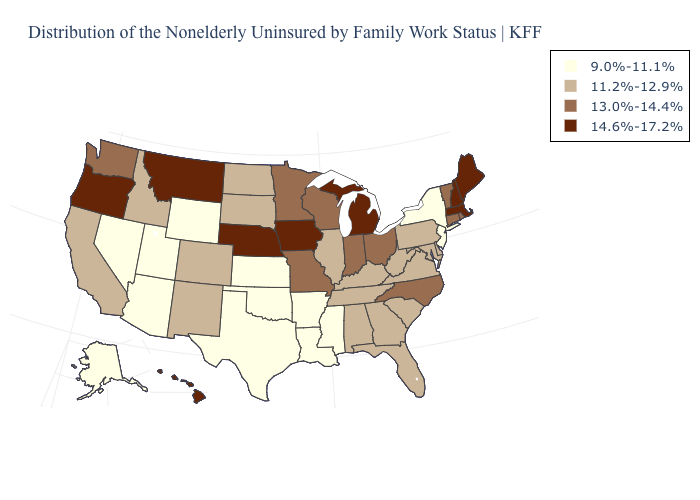Does Alaska have the lowest value in the USA?
Write a very short answer. Yes. Name the states that have a value in the range 14.6%-17.2%?
Keep it brief. Hawaii, Iowa, Maine, Massachusetts, Michigan, Montana, Nebraska, New Hampshire, Oregon. Name the states that have a value in the range 14.6%-17.2%?
Concise answer only. Hawaii, Iowa, Maine, Massachusetts, Michigan, Montana, Nebraska, New Hampshire, Oregon. What is the lowest value in states that border Kentucky?
Short answer required. 11.2%-12.9%. Does the map have missing data?
Be succinct. No. Does West Virginia have a lower value than Colorado?
Be succinct. No. Among the states that border Illinois , which have the highest value?
Quick response, please. Iowa. How many symbols are there in the legend?
Write a very short answer. 4. Among the states that border Ohio , does Michigan have the highest value?
Give a very brief answer. Yes. Is the legend a continuous bar?
Give a very brief answer. No. Name the states that have a value in the range 13.0%-14.4%?
Be succinct. Connecticut, Indiana, Minnesota, Missouri, North Carolina, Ohio, Rhode Island, Vermont, Washington, Wisconsin. Does Ohio have the lowest value in the USA?
Give a very brief answer. No. What is the highest value in states that border Alabama?
Answer briefly. 11.2%-12.9%. What is the highest value in states that border Mississippi?
Concise answer only. 11.2%-12.9%. 